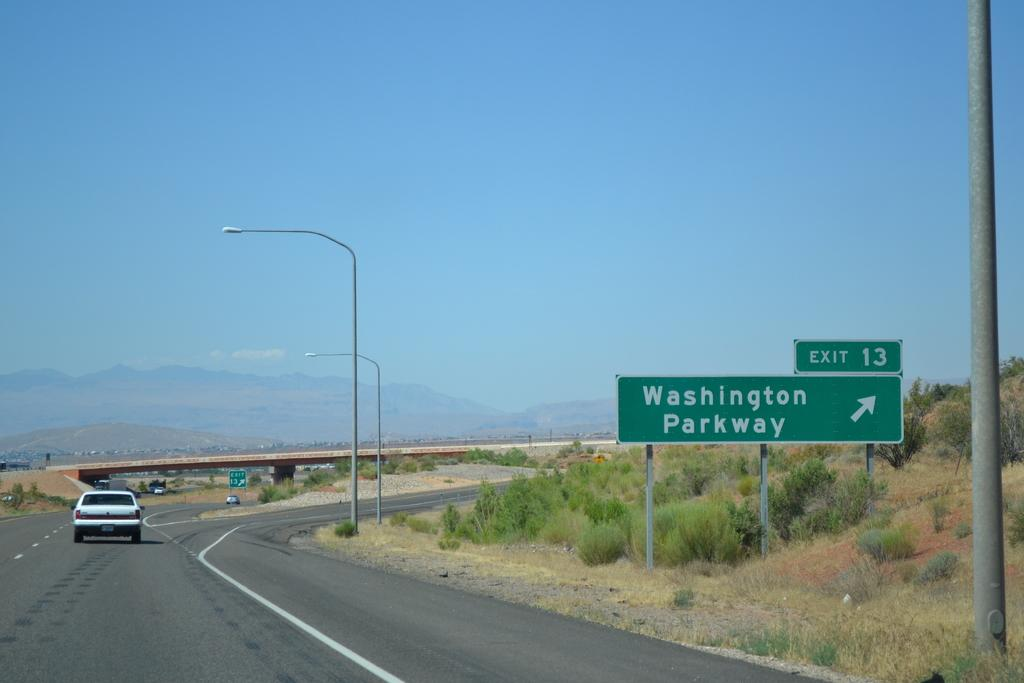<image>
Share a concise interpretation of the image provided. Exit 13 from the highway is for Washington Parkway. 